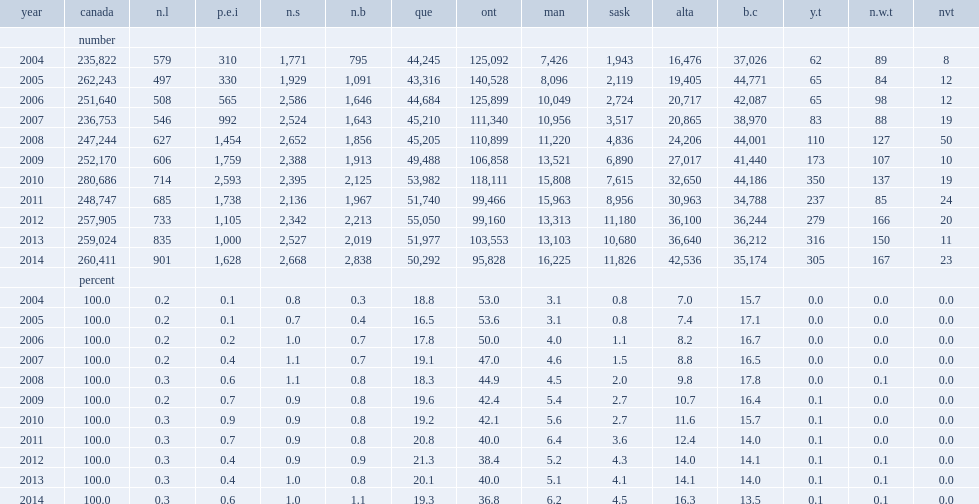How many new arrivals did british columbia admit in 2012? 36244.0. How many new arrivals did british columbia admit in 2013? 36212.0. How many immigrants did british columbia admit in 2014? 35174.0. How many percentage points did british columbia attract immigrants to canada in 2014? 13.5. How many percentage points did immigrants settle in manitoba in 2014? 6.2. How many percentage points did immigrants settle in prince edward island in 2014? 0.6. 